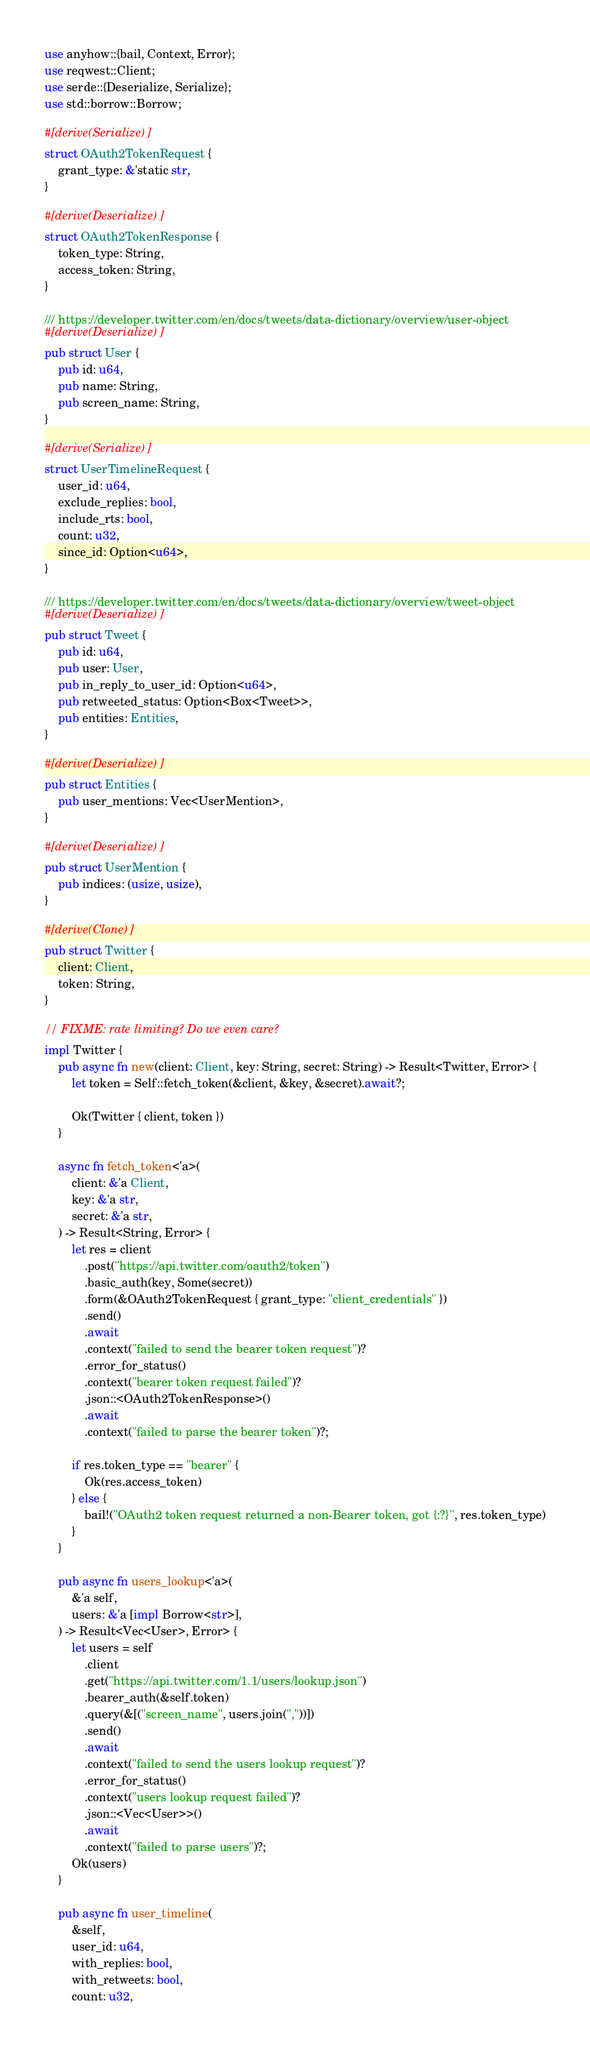<code> <loc_0><loc_0><loc_500><loc_500><_Rust_>use anyhow::{bail, Context, Error};
use reqwest::Client;
use serde::{Deserialize, Serialize};
use std::borrow::Borrow;

#[derive(Serialize)]
struct OAuth2TokenRequest {
    grant_type: &'static str,
}

#[derive(Deserialize)]
struct OAuth2TokenResponse {
    token_type: String,
    access_token: String,
}

/// https://developer.twitter.com/en/docs/tweets/data-dictionary/overview/user-object
#[derive(Deserialize)]
pub struct User {
    pub id: u64,
    pub name: String,
    pub screen_name: String,
}

#[derive(Serialize)]
struct UserTimelineRequest {
    user_id: u64,
    exclude_replies: bool,
    include_rts: bool,
    count: u32,
    since_id: Option<u64>,
}

/// https://developer.twitter.com/en/docs/tweets/data-dictionary/overview/tweet-object
#[derive(Deserialize)]
pub struct Tweet {
    pub id: u64,
    pub user: User,
    pub in_reply_to_user_id: Option<u64>,
    pub retweeted_status: Option<Box<Tweet>>,
    pub entities: Entities,
}

#[derive(Deserialize)]
pub struct Entities {
    pub user_mentions: Vec<UserMention>,
}

#[derive(Deserialize)]
pub struct UserMention {
    pub indices: (usize, usize),
}

#[derive(Clone)]
pub struct Twitter {
    client: Client,
    token: String,
}

// FIXME: rate limiting? Do we even care?
impl Twitter {
    pub async fn new(client: Client, key: String, secret: String) -> Result<Twitter, Error> {
        let token = Self::fetch_token(&client, &key, &secret).await?;

        Ok(Twitter { client, token })
    }

    async fn fetch_token<'a>(
        client: &'a Client,
        key: &'a str,
        secret: &'a str,
    ) -> Result<String, Error> {
        let res = client
            .post("https://api.twitter.com/oauth2/token")
            .basic_auth(key, Some(secret))
            .form(&OAuth2TokenRequest { grant_type: "client_credentials" })
            .send()
            .await
            .context("failed to send the bearer token request")?
            .error_for_status()
            .context("bearer token request failed")?
            .json::<OAuth2TokenResponse>()
            .await
            .context("failed to parse the bearer token")?;

        if res.token_type == "bearer" {
            Ok(res.access_token)
        } else {
            bail!("OAuth2 token request returned a non-Bearer token, got {:?}", res.token_type)
        }
    }

    pub async fn users_lookup<'a>(
        &'a self,
        users: &'a [impl Borrow<str>],
    ) -> Result<Vec<User>, Error> {
        let users = self
            .client
            .get("https://api.twitter.com/1.1/users/lookup.json")
            .bearer_auth(&self.token)
            .query(&[("screen_name", users.join(","))])
            .send()
            .await
            .context("failed to send the users lookup request")?
            .error_for_status()
            .context("users lookup request failed")?
            .json::<Vec<User>>()
            .await
            .context("failed to parse users")?;
        Ok(users)
    }

    pub async fn user_timeline(
        &self,
        user_id: u64,
        with_replies: bool,
        with_retweets: bool,
        count: u32,</code> 